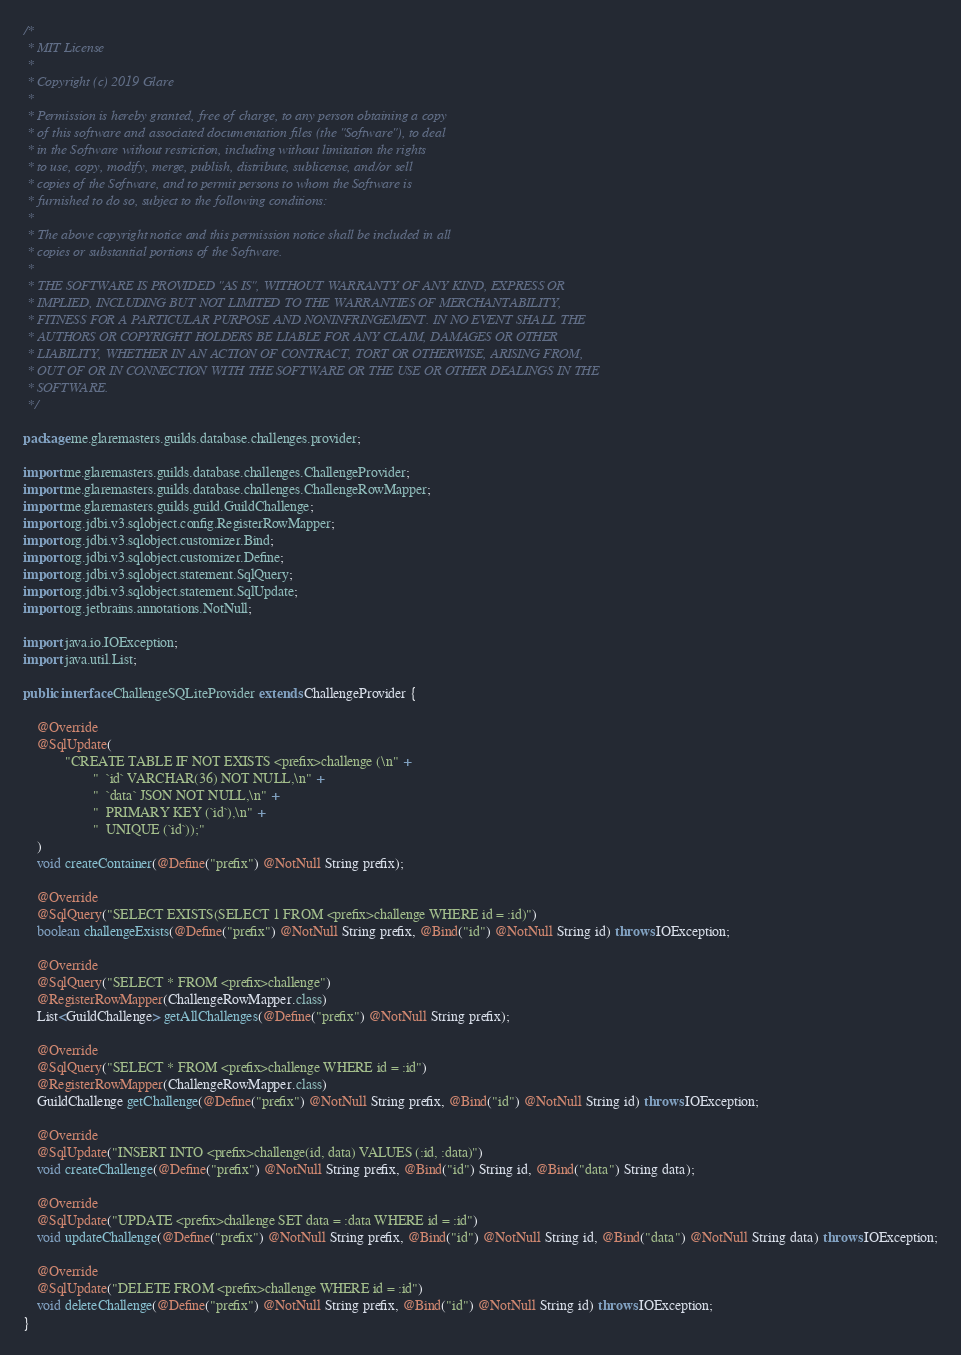<code> <loc_0><loc_0><loc_500><loc_500><_Java_>/*
 * MIT License
 *
 * Copyright (c) 2019 Glare
 *
 * Permission is hereby granted, free of charge, to any person obtaining a copy
 * of this software and associated documentation files (the "Software"), to deal
 * in the Software without restriction, including without limitation the rights
 * to use, copy, modify, merge, publish, distribute, sublicense, and/or sell
 * copies of the Software, and to permit persons to whom the Software is
 * furnished to do so, subject to the following conditions:
 *
 * The above copyright notice and this permission notice shall be included in all
 * copies or substantial portions of the Software.
 *
 * THE SOFTWARE IS PROVIDED "AS IS", WITHOUT WARRANTY OF ANY KIND, EXPRESS OR
 * IMPLIED, INCLUDING BUT NOT LIMITED TO THE WARRANTIES OF MERCHANTABILITY,
 * FITNESS FOR A PARTICULAR PURPOSE AND NONINFRINGEMENT. IN NO EVENT SHALL THE
 * AUTHORS OR COPYRIGHT HOLDERS BE LIABLE FOR ANY CLAIM, DAMAGES OR OTHER
 * LIABILITY, WHETHER IN AN ACTION OF CONTRACT, TORT OR OTHERWISE, ARISING FROM,
 * OUT OF OR IN CONNECTION WITH THE SOFTWARE OR THE USE OR OTHER DEALINGS IN THE
 * SOFTWARE.
 */

package me.glaremasters.guilds.database.challenges.provider;

import me.glaremasters.guilds.database.challenges.ChallengeProvider;
import me.glaremasters.guilds.database.challenges.ChallengeRowMapper;
import me.glaremasters.guilds.guild.GuildChallenge;
import org.jdbi.v3.sqlobject.config.RegisterRowMapper;
import org.jdbi.v3.sqlobject.customizer.Bind;
import org.jdbi.v3.sqlobject.customizer.Define;
import org.jdbi.v3.sqlobject.statement.SqlQuery;
import org.jdbi.v3.sqlobject.statement.SqlUpdate;
import org.jetbrains.annotations.NotNull;

import java.io.IOException;
import java.util.List;

public interface ChallengeSQLiteProvider extends ChallengeProvider {

    @Override
    @SqlUpdate(
            "CREATE TABLE IF NOT EXISTS <prefix>challenge (\n" +
                    "  `id` VARCHAR(36) NOT NULL,\n" +
                    "  `data` JSON NOT NULL,\n" +
                    "  PRIMARY KEY (`id`),\n" +
                    "  UNIQUE (`id`));"
    )
    void createContainer(@Define("prefix") @NotNull String prefix);

    @Override
    @SqlQuery("SELECT EXISTS(SELECT 1 FROM <prefix>challenge WHERE id = :id)")
    boolean challengeExists(@Define("prefix") @NotNull String prefix, @Bind("id") @NotNull String id) throws IOException;

    @Override
    @SqlQuery("SELECT * FROM <prefix>challenge")
    @RegisterRowMapper(ChallengeRowMapper.class)
    List<GuildChallenge> getAllChallenges(@Define("prefix") @NotNull String prefix);

    @Override
    @SqlQuery("SELECT * FROM <prefix>challenge WHERE id = :id")
    @RegisterRowMapper(ChallengeRowMapper.class)
    GuildChallenge getChallenge(@Define("prefix") @NotNull String prefix, @Bind("id") @NotNull String id) throws IOException;

    @Override
    @SqlUpdate("INSERT INTO <prefix>challenge(id, data) VALUES (:id, :data)")
    void createChallenge(@Define("prefix") @NotNull String prefix, @Bind("id") String id, @Bind("data") String data);

    @Override
    @SqlUpdate("UPDATE <prefix>challenge SET data = :data WHERE id = :id")
    void updateChallenge(@Define("prefix") @NotNull String prefix, @Bind("id") @NotNull String id, @Bind("data") @NotNull String data) throws IOException;

    @Override
    @SqlUpdate("DELETE FROM <prefix>challenge WHERE id = :id")
    void deleteChallenge(@Define("prefix") @NotNull String prefix, @Bind("id") @NotNull String id) throws IOException;
}
</code> 